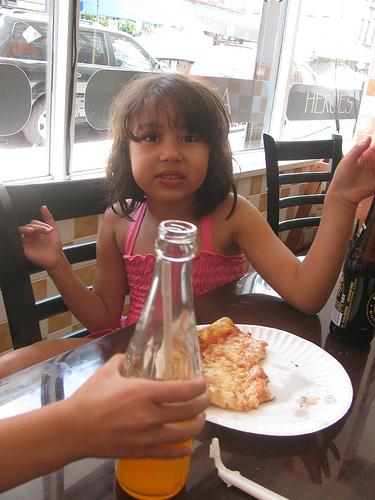Question: what color is the drink?
Choices:
A. Orange.
B. Green.
C. Blue.
D. Red.
Answer with the letter. Answer: A Question: what is this a photo of?
Choices:
A. Birds nesting.
B. A baby nursing.
C. People eating.
D. People shopping.
Answer with the letter. Answer: C Question: what is on the plate?
Choices:
A. Pizza.
B. A cheeseburger.
C. French fries.
D. Meatloaf.
Answer with the letter. Answer: A Question: how many hands can be seen?
Choices:
A. Three.
B. Four.
C. Five.
D. Six.
Answer with the letter. Answer: A 